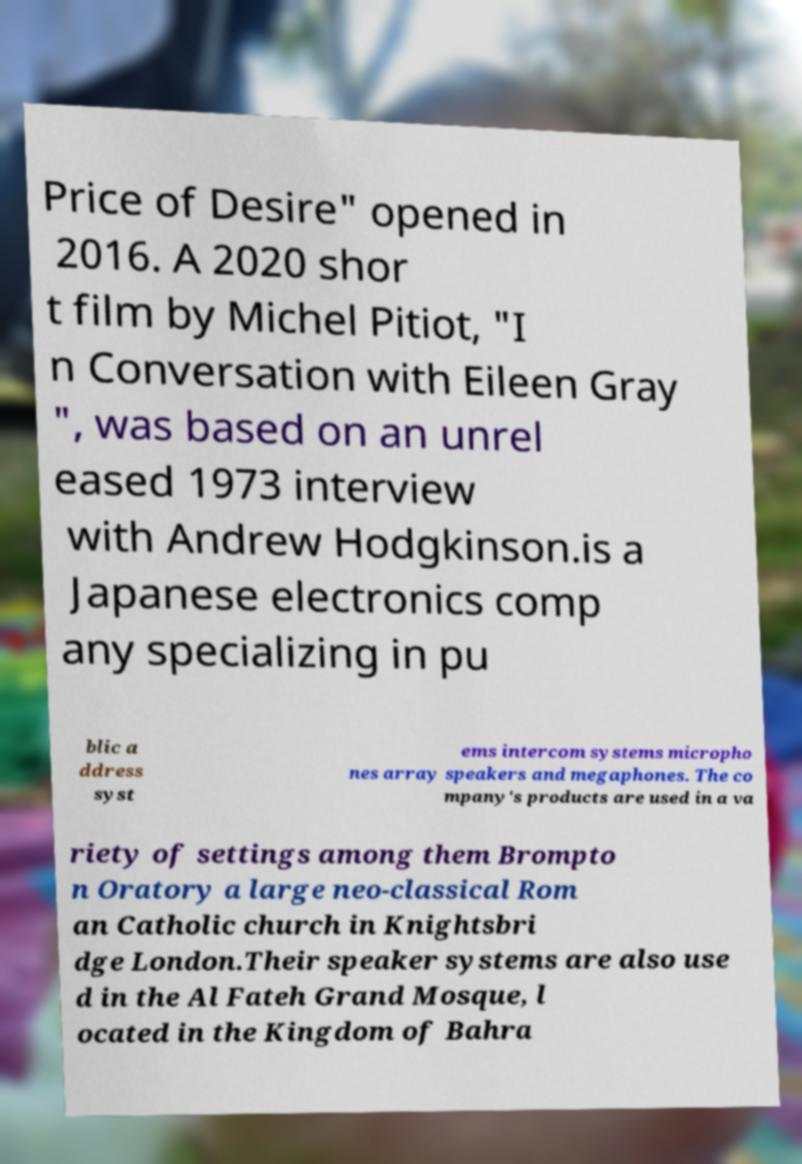There's text embedded in this image that I need extracted. Can you transcribe it verbatim? Price of Desire" opened in 2016. A 2020 shor t film by Michel Pitiot, "I n Conversation with Eileen Gray ", was based on an unrel eased 1973 interview with Andrew Hodgkinson.is a Japanese electronics comp any specializing in pu blic a ddress syst ems intercom systems micropho nes array speakers and megaphones. The co mpany's products are used in a va riety of settings among them Brompto n Oratory a large neo-classical Rom an Catholic church in Knightsbri dge London.Their speaker systems are also use d in the Al Fateh Grand Mosque, l ocated in the Kingdom of Bahra 